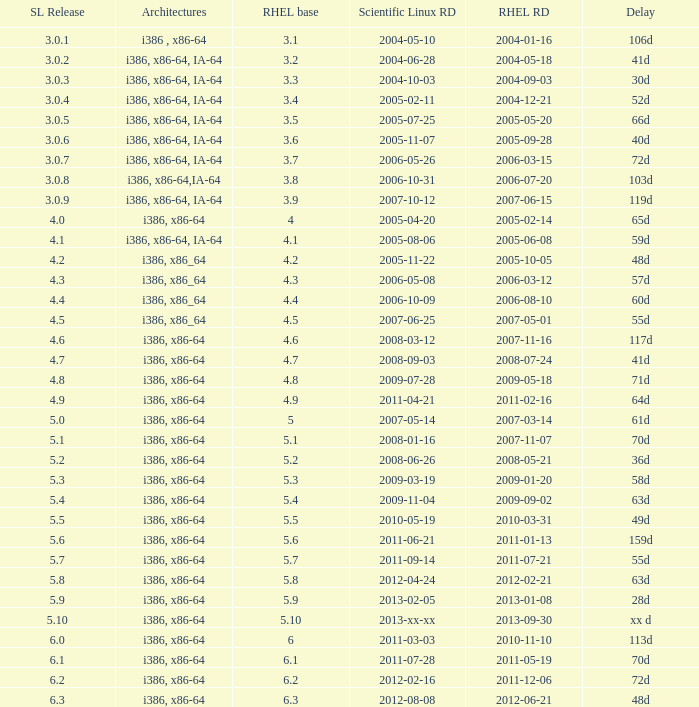When is the rhel release date when scientific linux release is 3.0.4 2004-12-21. 